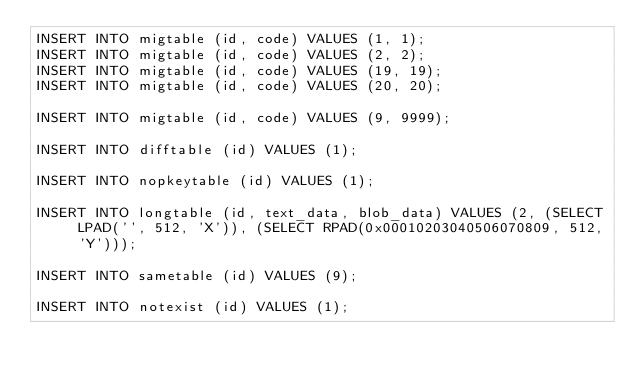<code> <loc_0><loc_0><loc_500><loc_500><_SQL_>INSERT INTO migtable (id, code) VALUES (1, 1);
INSERT INTO migtable (id, code) VALUES (2, 2);
INSERT INTO migtable (id, code) VALUES (19, 19);
INSERT INTO migtable (id, code) VALUES (20, 20);

INSERT INTO migtable (id, code) VALUES (9, 9999);

INSERT INTO difftable (id) VALUES (1);

INSERT INTO nopkeytable (id) VALUES (1);

INSERT INTO longtable (id, text_data, blob_data) VALUES (2, (SELECT LPAD('', 512, 'X')), (SELECT RPAD(0x00010203040506070809, 512, 'Y')));

INSERT INTO sametable (id) VALUES (9);

INSERT INTO notexist (id) VALUES (1);
</code> 